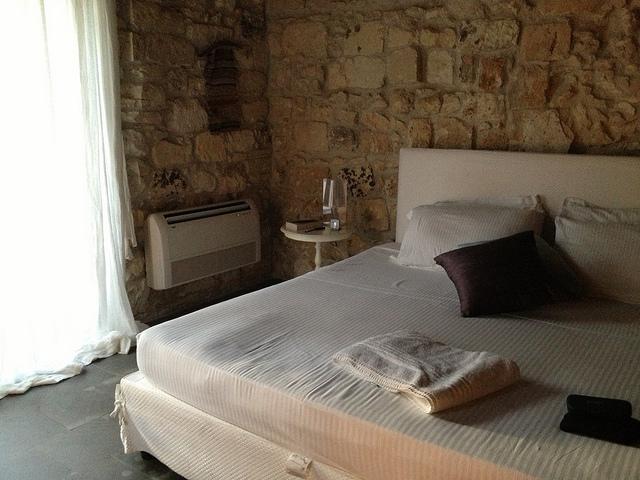Is the bed made?
Concise answer only. Yes. What kind of wall is it?
Give a very brief answer. Stone. Is this a hotel room?
Write a very short answer. Yes. 